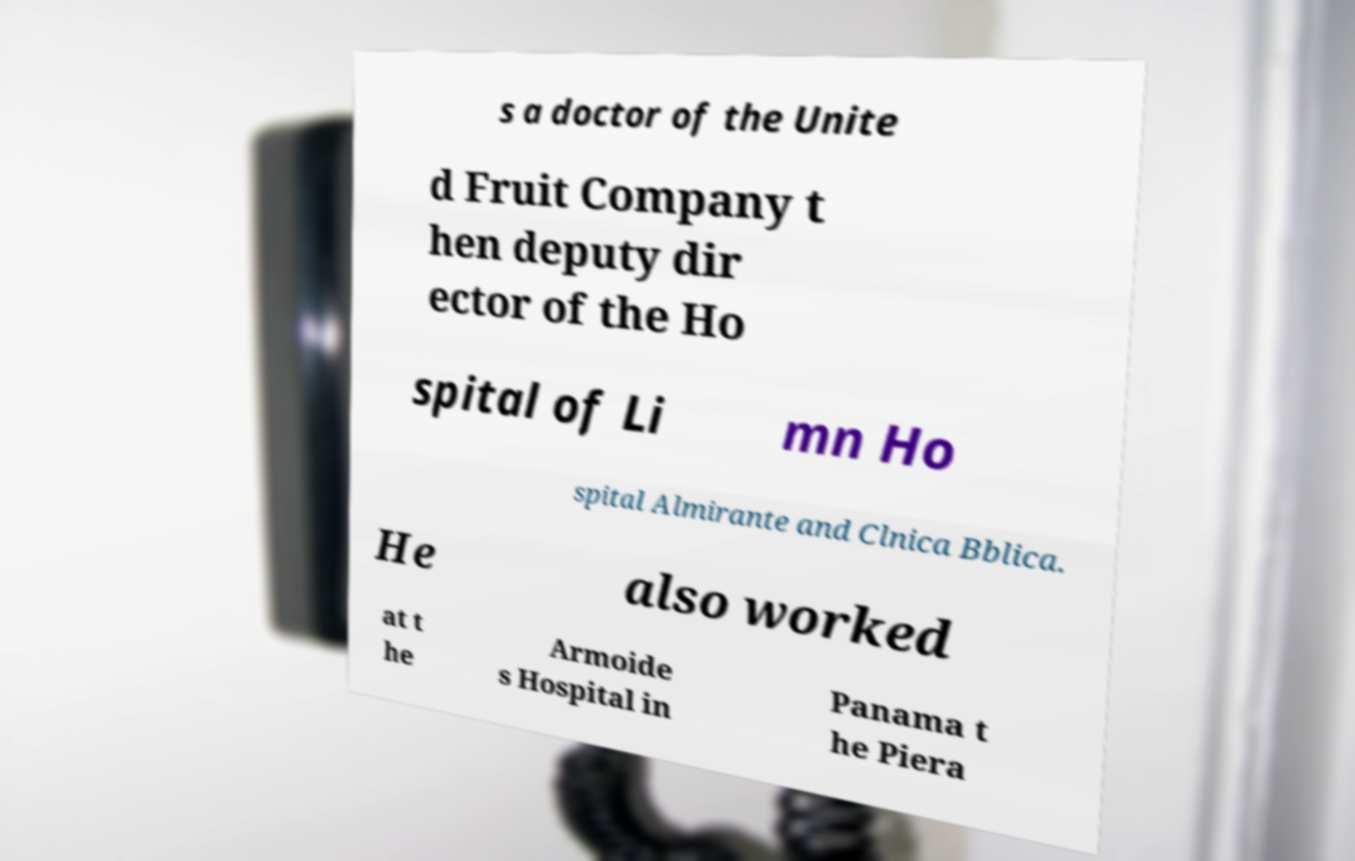Could you extract and type out the text from this image? s a doctor of the Unite d Fruit Company t hen deputy dir ector of the Ho spital of Li mn Ho spital Almirante and Clnica Bblica. He also worked at t he Armoide s Hospital in Panama t he Piera 